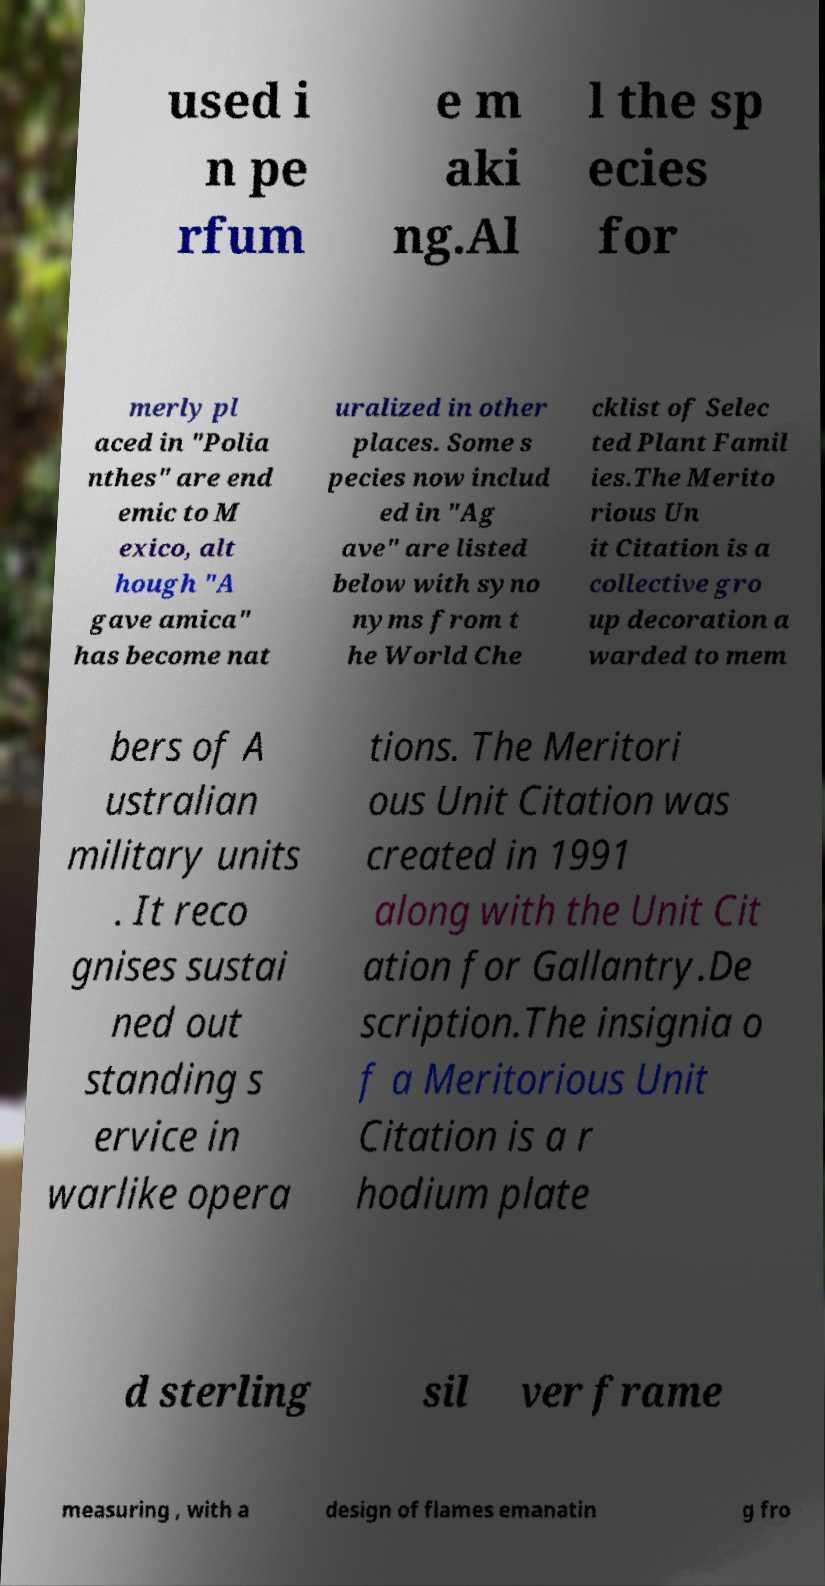Can you accurately transcribe the text from the provided image for me? used i n pe rfum e m aki ng.Al l the sp ecies for merly pl aced in "Polia nthes" are end emic to M exico, alt hough "A gave amica" has become nat uralized in other places. Some s pecies now includ ed in "Ag ave" are listed below with syno nyms from t he World Che cklist of Selec ted Plant Famil ies.The Merito rious Un it Citation is a collective gro up decoration a warded to mem bers of A ustralian military units . It reco gnises sustai ned out standing s ervice in warlike opera tions. The Meritori ous Unit Citation was created in 1991 along with the Unit Cit ation for Gallantry.De scription.The insignia o f a Meritorious Unit Citation is a r hodium plate d sterling sil ver frame measuring , with a design of flames emanatin g fro 